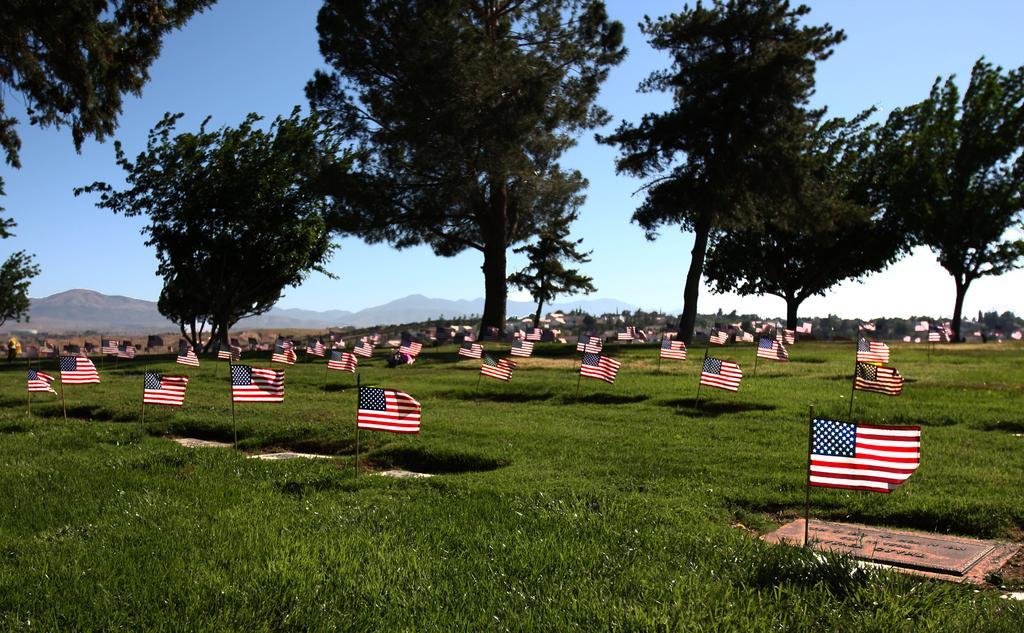Can you describe this image briefly? In this image we can see a group of flags placed in an order with poles on the ground. We can also see some grass and a group of trees. On the backside we can see some buildings, the mountains and the sky which looks cloudy. 